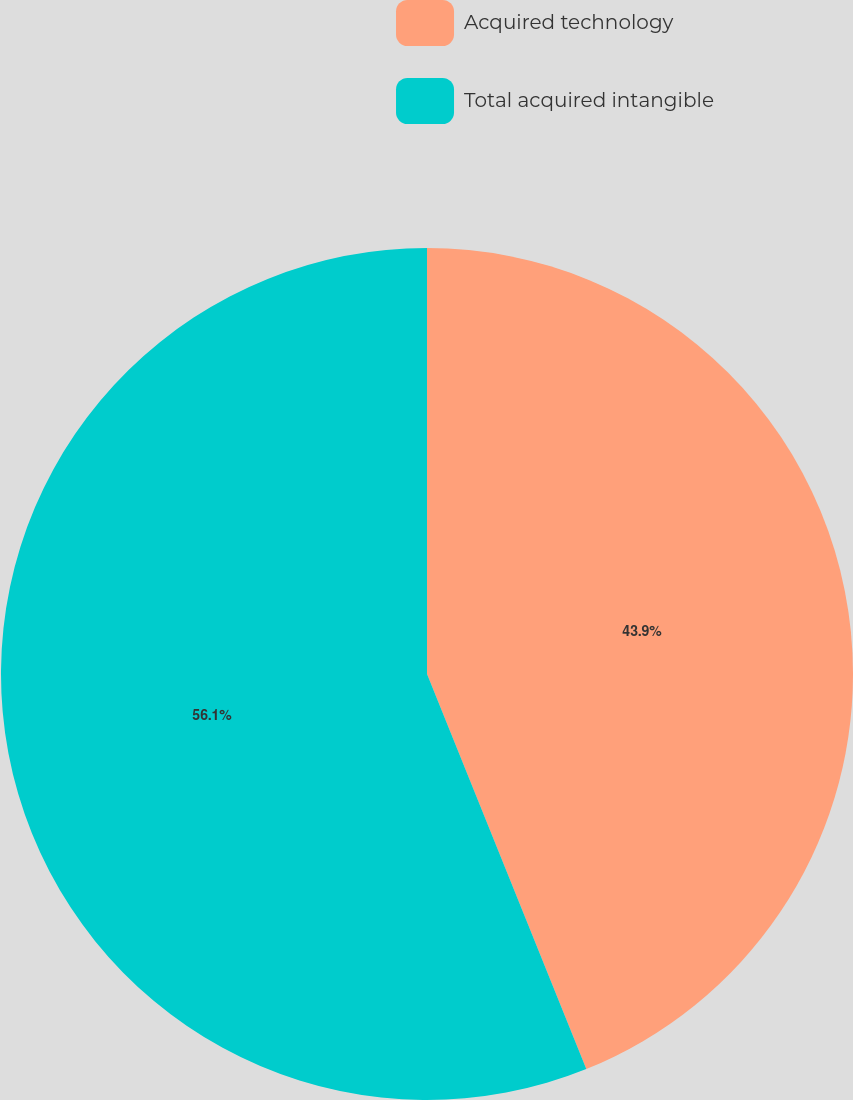Convert chart. <chart><loc_0><loc_0><loc_500><loc_500><pie_chart><fcel>Acquired technology<fcel>Total acquired intangible<nl><fcel>43.9%<fcel>56.1%<nl></chart> 